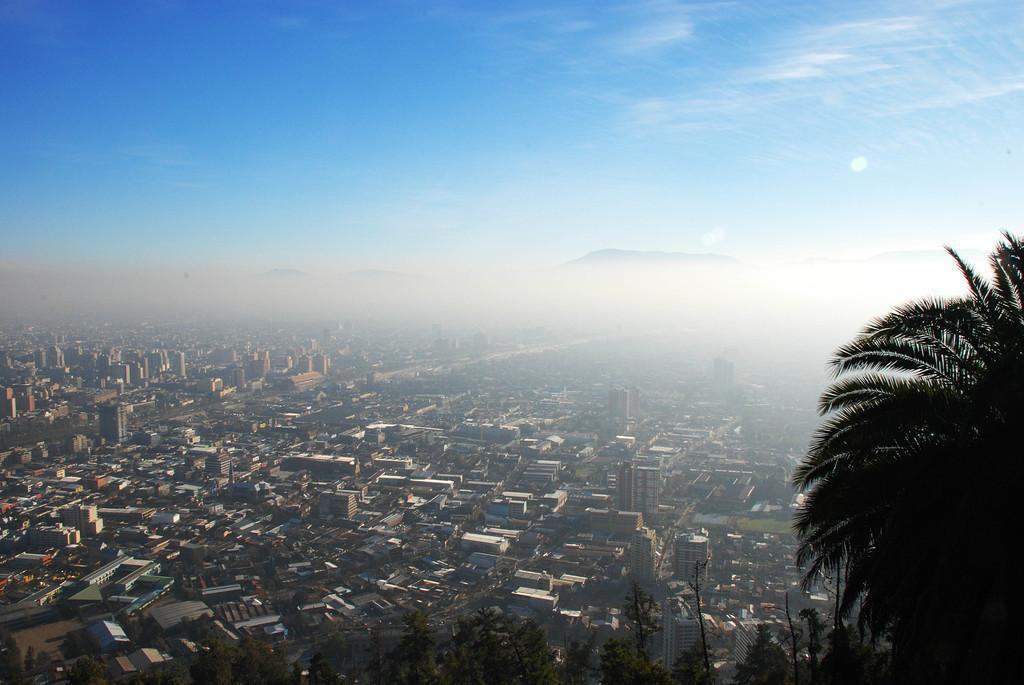Describe this image in one or two sentences. This is an aerial view, where we can see a city, the sky, clouds and on the bottom of the image, there are trees. 